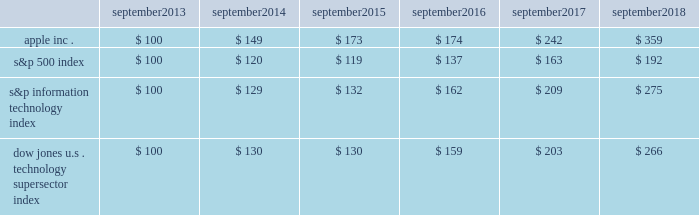Apple inc .
| 2018 form 10-k | 20 company stock performance the following graph shows a comparison of cumulative total shareholder return , calculated on a dividend-reinvested basis , for the company , the s&p 500 index , the s&p information technology index and the dow jones u.s .
Technology supersector index for the five years ended september 29 , 2018 .
The graph assumes $ 100 was invested in each of the company 2019s common stock , the s&p 500 index , the s&p information technology index and the dow jones u.s .
Technology supersector index as of the market close on september 27 , 2013 .
Note that historic stock price performance is not necessarily indicative of future stock price performance .
* $ 100 invested on september 27 , 2013 in stock or index , including reinvestment of dividends .
Data points are the last day of each fiscal year for the company 2019s common stock and september 30th for indexes .
Copyright a9 2018 standard & poor 2019s , a division of s&p global .
All rights reserved .
Copyright a9 2018 s&p dow jones indices llc , a division of s&p global .
All rights reserved .
September september september september september september .

What is the difference in percentage cumulative total return between apple inc . and the s&p 500 index for the five year period ended september 2018? 
Computations: (((359 - 100) / 100) - ((192 - 100) / 100))
Answer: 1.67. 